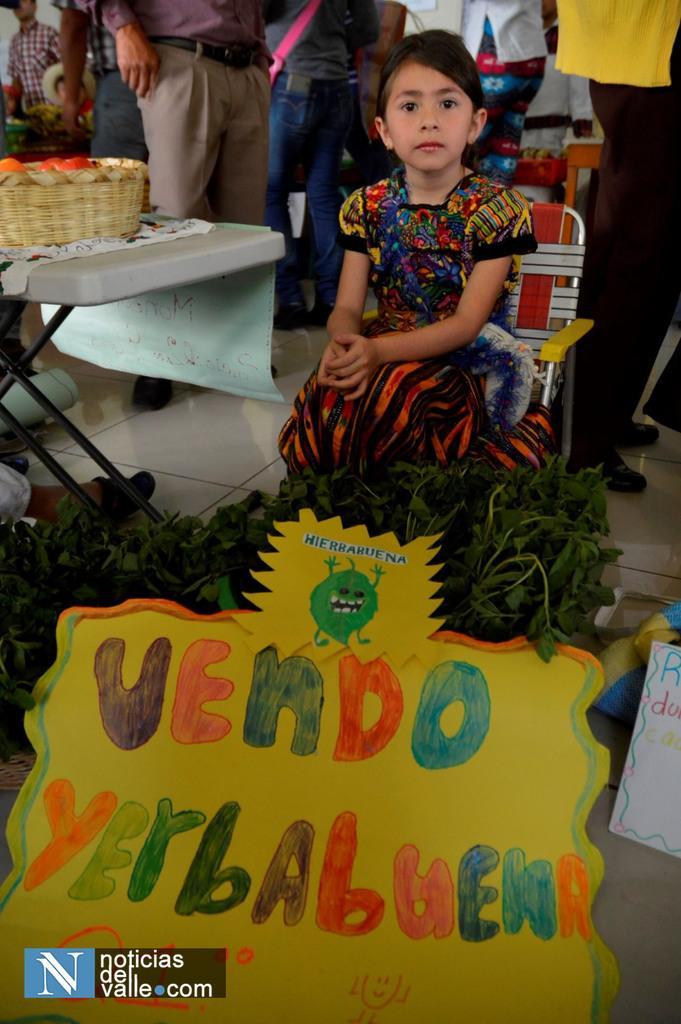Please provide a concise description of this image. In the center of the image we can see a girl sitting. At the bottom there are boards and we can see leafy vegetables. On the left there is a table and we can see basket placed on the table. In the background there are people. 